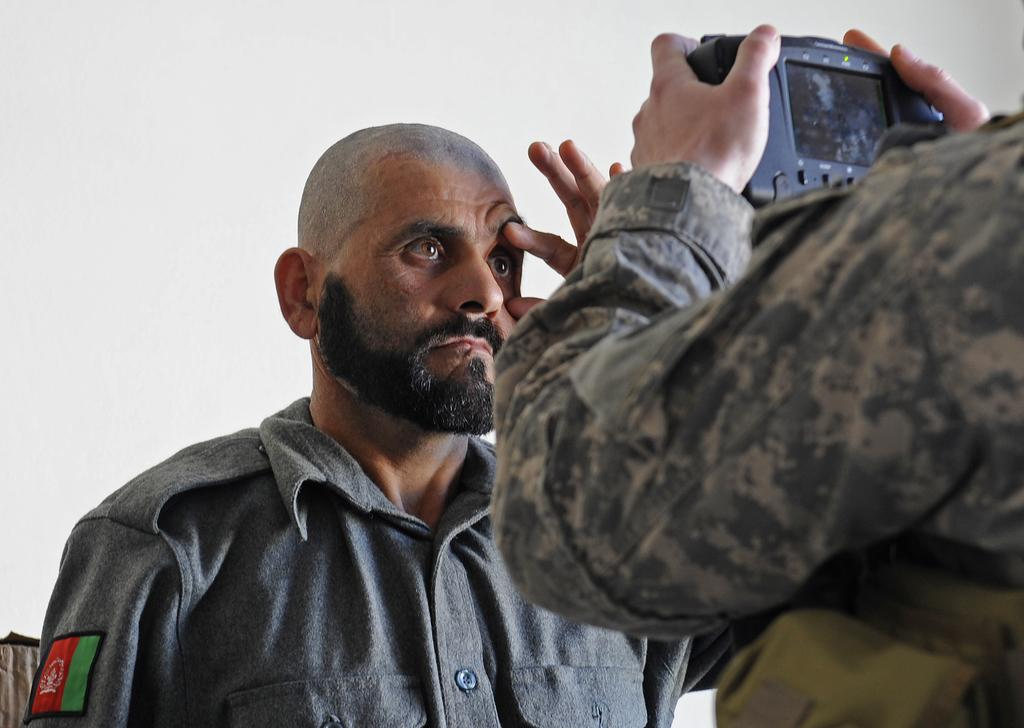Who is the main subject in the image? There is a man in the image. What is the man in the image doing? The man is standing in front of another man. What is the man in front holding? The man in front is holding a camera in his hands. What is the color of the background in the image? The background of the image is white. What type of operation is being performed on the leaf in the image? There is no leaf present in the image, and therefore no operation is being performed on it. 